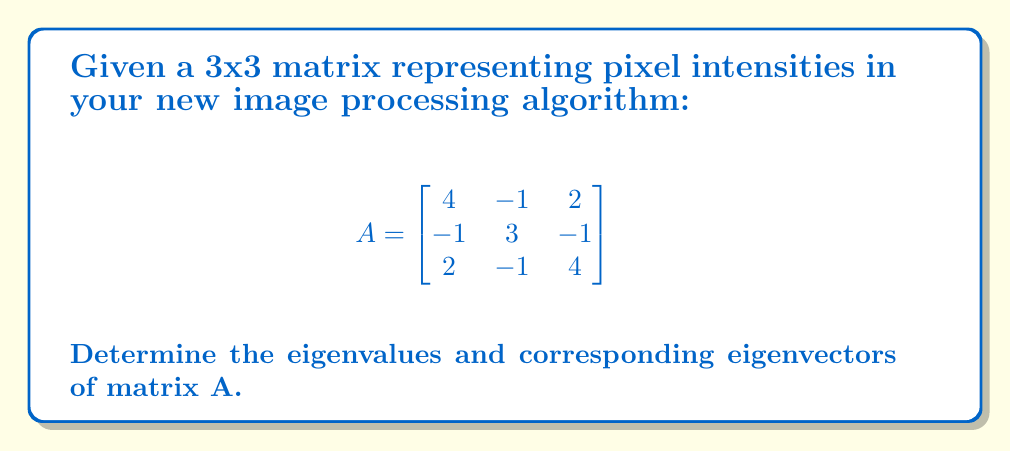Could you help me with this problem? To find the eigenvalues and eigenvectors of matrix A, we follow these steps:

1. Find the characteristic equation:
   $det(A - \lambda I) = 0$

   $$\begin{vmatrix}
   4-\lambda & -1 & 2 \\
   -1 & 3-\lambda & -1 \\
   2 & -1 & 4-\lambda
   \end{vmatrix} = 0$$

2. Expand the determinant:
   $(4-\lambda)[(3-\lambda)(4-\lambda) - 1] + (-1)[(-1)(4-\lambda) - 2(-1)] + 2[(-1)(-1) - (3-\lambda)(2)] = 0$

3. Simplify:
   $(4-\lambda)[(12-7\lambda+\lambda^2) - 1] + (-1)[-4+\lambda+2] + 2[1 - 6+2\lambda] = 0$
   $(4-\lambda)(11-7\lambda+\lambda^2) + (-1)(-2+\lambda) + 2(-5+2\lambda) = 0$
   $44-28\lambda+4\lambda^2-11\lambda+7\lambda^2-\lambda^3 + 2-\lambda + -10+4\lambda = 0$

4. Combine like terms:
   $-\lambda^3 + 11\lambda^2 - 25\lambda + 36 = 0$

5. Factor the equation:
   $-(\lambda - 2)(\lambda - 3)(\lambda - 6) = 0$

6. Solve for eigenvalues:
   $\lambda_1 = 2, \lambda_2 = 3, \lambda_3 = 6$

7. Find eigenvectors for each eigenvalue:
   For $\lambda_1 = 2$:
   $(A - 2I)v = 0$
   Solve: $\begin{bmatrix} 2 & -1 & 2 \\ -1 & 1 & -1 \\ 2 & -1 & 2 \end{bmatrix} \begin{bmatrix} v_1 \\ v_2 \\ v_3 \end{bmatrix} = \begin{bmatrix} 0 \\ 0 \\ 0 \end{bmatrix}$
   Eigenvector: $v_1 = \begin{bmatrix} 1 \\ 2 \\ 1 \end{bmatrix}$

   For $\lambda_2 = 3$:
   $(A - 3I)v = 0$
   Solve: $\begin{bmatrix} 1 & -1 & 2 \\ -1 & 0 & -1 \\ 2 & -1 & 1 \end{bmatrix} \begin{bmatrix} v_1 \\ v_2 \\ v_3 \end{bmatrix} = \begin{bmatrix} 0 \\ 0 \\ 0 \end{bmatrix}$
   Eigenvector: $v_2 = \begin{bmatrix} 1 \\ 0 \\ -1 \end{bmatrix}$

   For $\lambda_3 = 6$:
   $(A - 6I)v = 0$
   Solve: $\begin{bmatrix} -2 & -1 & 2 \\ -1 & -3 & -1 \\ 2 & -1 & -2 \end{bmatrix} \begin{bmatrix} v_1 \\ v_2 \\ v_3 \end{bmatrix} = \begin{bmatrix} 0 \\ 0 \\ 0 \end{bmatrix}$
   Eigenvector: $v_3 = \begin{bmatrix} 1 \\ -1 \\ 1 \end{bmatrix}$
Answer: Eigenvalues: $\lambda_1 = 2, \lambda_2 = 3, \lambda_3 = 6$
Eigenvectors: $v_1 = \begin{bmatrix} 1 \\ 2 \\ 1 \end{bmatrix}, v_2 = \begin{bmatrix} 1 \\ 0 \\ -1 \end{bmatrix}, v_3 = \begin{bmatrix} 1 \\ -1 \\ 1 \end{bmatrix}$ 